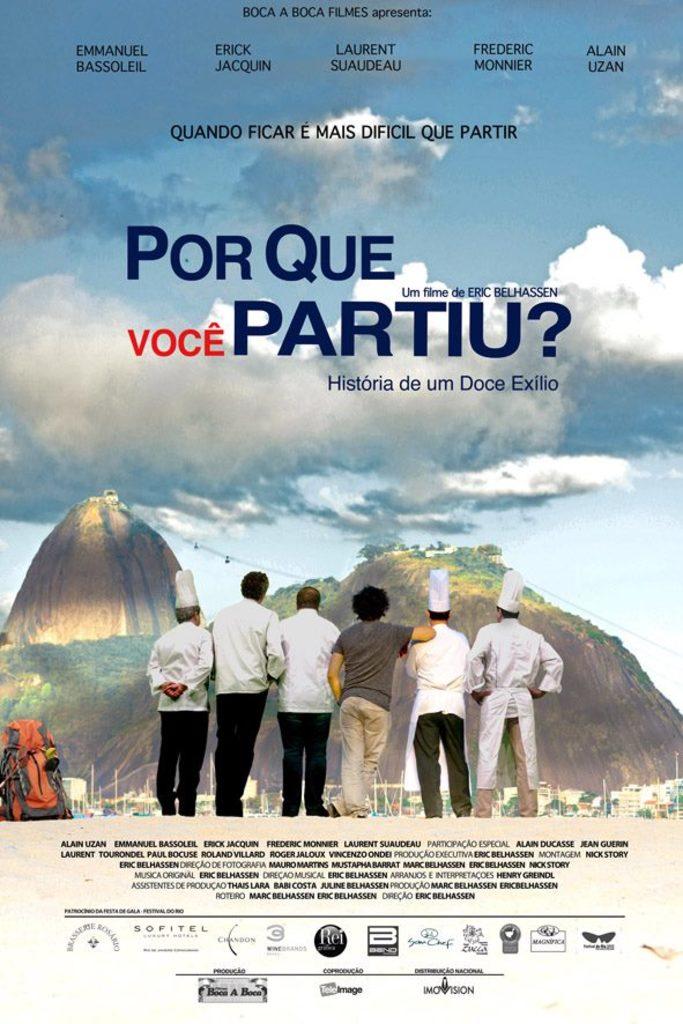What is this an advert for?
Give a very brief answer. A movie. What language is this in?
Your response must be concise. Spanish. 